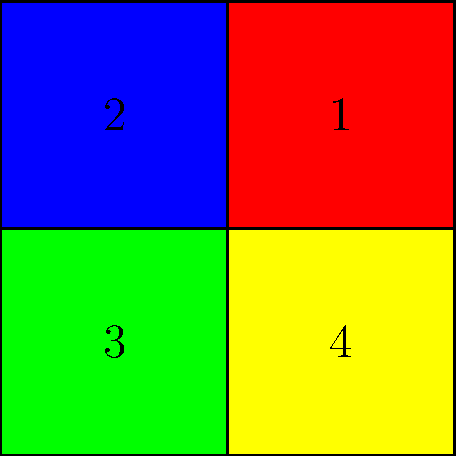Look at the colorful blocks puzzle. If you rotate block 1 clockwise once, block 2 counterclockwise twice, and block 4 clockwise three times, which block will be pointing up? Let's go through this step-by-step:

1. Block 1 (red) is rotated clockwise once (90 degrees). It will now point to the right.
2. Block 2 (blue) is rotated counterclockwise twice (180 degrees). It will now point down.
3. Block 3 (green) is not rotated. It remains pointing left.
4. Block 4 (yellow) is rotated clockwise three times (270 degrees). It will now point up.

After these rotations, we can see that only block 4 (yellow) will be pointing up.
Answer: Yellow block (4) 